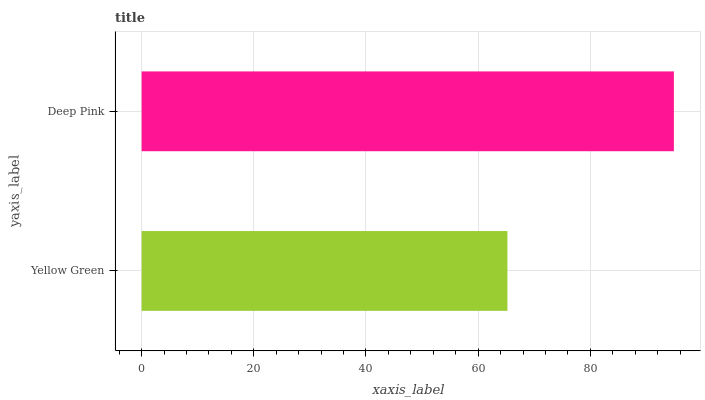Is Yellow Green the minimum?
Answer yes or no. Yes. Is Deep Pink the maximum?
Answer yes or no. Yes. Is Deep Pink the minimum?
Answer yes or no. No. Is Deep Pink greater than Yellow Green?
Answer yes or no. Yes. Is Yellow Green less than Deep Pink?
Answer yes or no. Yes. Is Yellow Green greater than Deep Pink?
Answer yes or no. No. Is Deep Pink less than Yellow Green?
Answer yes or no. No. Is Deep Pink the high median?
Answer yes or no. Yes. Is Yellow Green the low median?
Answer yes or no. Yes. Is Yellow Green the high median?
Answer yes or no. No. Is Deep Pink the low median?
Answer yes or no. No. 